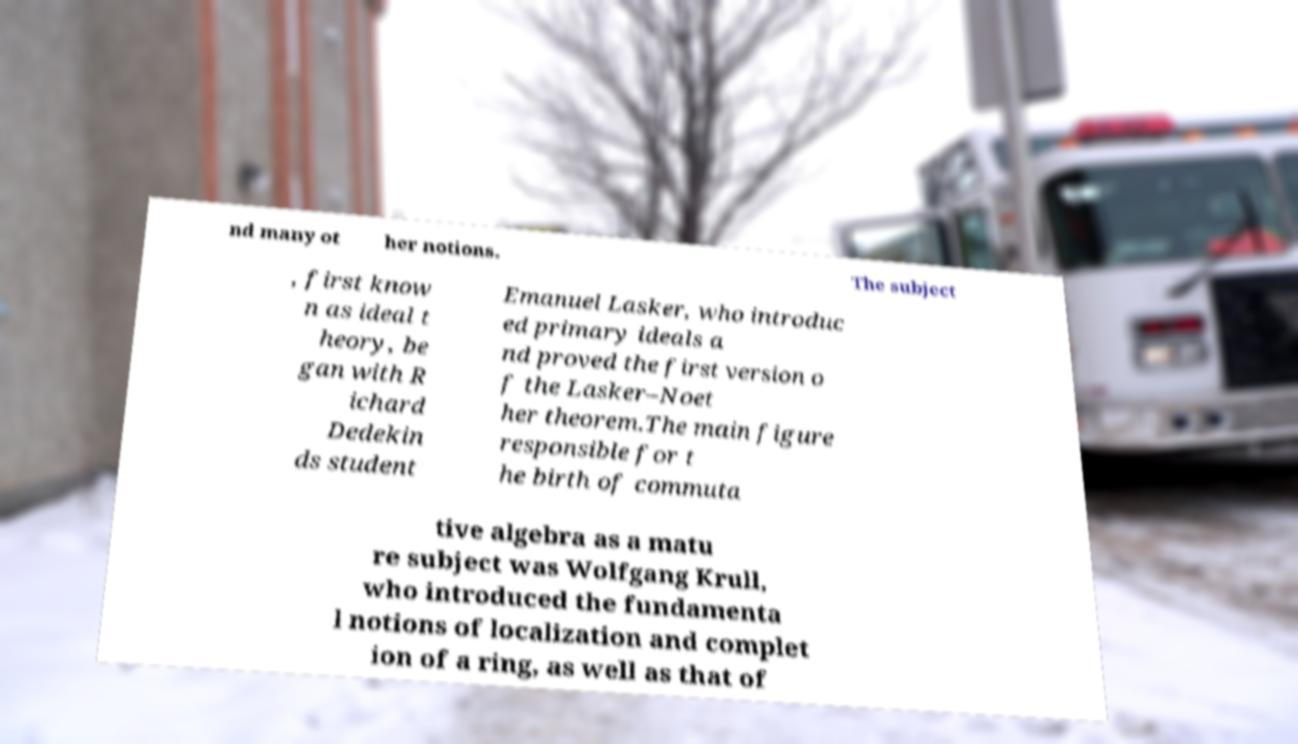For documentation purposes, I need the text within this image transcribed. Could you provide that? nd many ot her notions. The subject , first know n as ideal t heory, be gan with R ichard Dedekin ds student Emanuel Lasker, who introduc ed primary ideals a nd proved the first version o f the Lasker–Noet her theorem.The main figure responsible for t he birth of commuta tive algebra as a matu re subject was Wolfgang Krull, who introduced the fundamenta l notions of localization and complet ion of a ring, as well as that of 